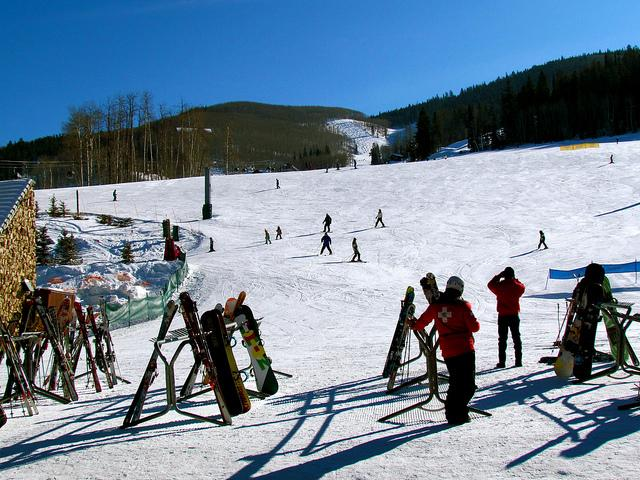The instrument in the picture is used to play for?

Choices:
A) snowboarding
B) skiing
C) surfing
D) skating skiing 